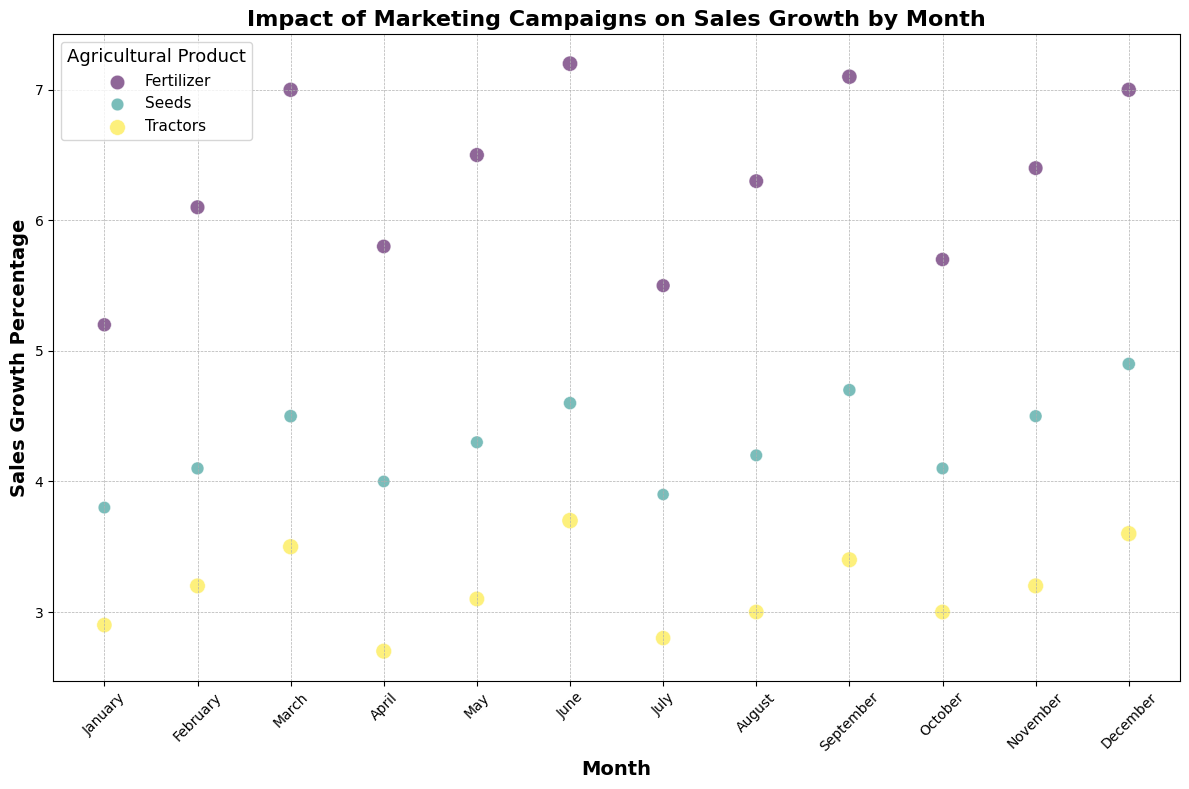What's the product with the highest sales growth percentage in March? First, locate March on the x-axis. Then identify the bubbles corresponding to March. Compare the values of Sales Growth Percentage for these bubbles to find the highest one.
Answer: Fertilizer Which month had the highest marketing spend for Seeds? Locate all the bubbles for the Seeds category. Compare their sizes across different months since the bubble size represents marketing spend. Identify the month with the largest bubble.
Answer: December Is there a month where Fertilizer had a higher sales growth percentage than both Seeds and Tractors? Examine each month's bubbles for the three products and compare their sales growth percentages. Determine if Ferilizer's value exceeds those of Seeds and Tractors in any month.
Answer: March, June, September, December What's the average sales growth percentage for Tractors across all months? Sum the sales growth percentages for Tractors from all months and divide by the total number of months. Calculation: (2.9 + 3.2 + 3.5 + 2.7 + 3.1 + 3.7 + 2.8 + 3.0 + 3.4 + 3.0 + 3.2 + 3.6) / 12 = 3.16
Answer: 3.16 Which product has the most consistent sales growth percentage across months? Examine the fluctuations in the sales growth percentages for each product across months, noting which product has the least variation.
Answer: Seeds In which month did Seeds have its lowest sales growth percentage? Locate the bubbles representing Seeds across all months, then identify which has the smallest y-value.
Answer: January During which month did Fertilizer have the lowest marketing spend, and what was the sales growth percentage during that month? Find the smallest bubble size for Fertilizer and note both the month and the associated sales growth percentage.
Answer: July, 5.5% Which month saw the biggest difference in sales growth percentage between Fertilizer and Tractors? For each month, calculate the absolute difference in sales growth percentages between Fertilizer and Tractors. Identify the month with the largest difference.
Answer: June Did Fertilizer's marketing spend in December result in a higher sales growth percentage compared to its marketing spend in July? Compare the sizes of the Fertilizer bubbles and their respective sales growth percentages for December and July. December shows a higher bubble size and higher sales growth percentage of 7.0% compared to 5.5% in July
Answer: Yes In which month did Seeds outperform Tractors in sales growth the most? Calculate the difference in sales growth percentages between Seeds and Tractors for each month. Identify the month with the largest positive difference where Seeds exceeded Tractors.
Answer: December 